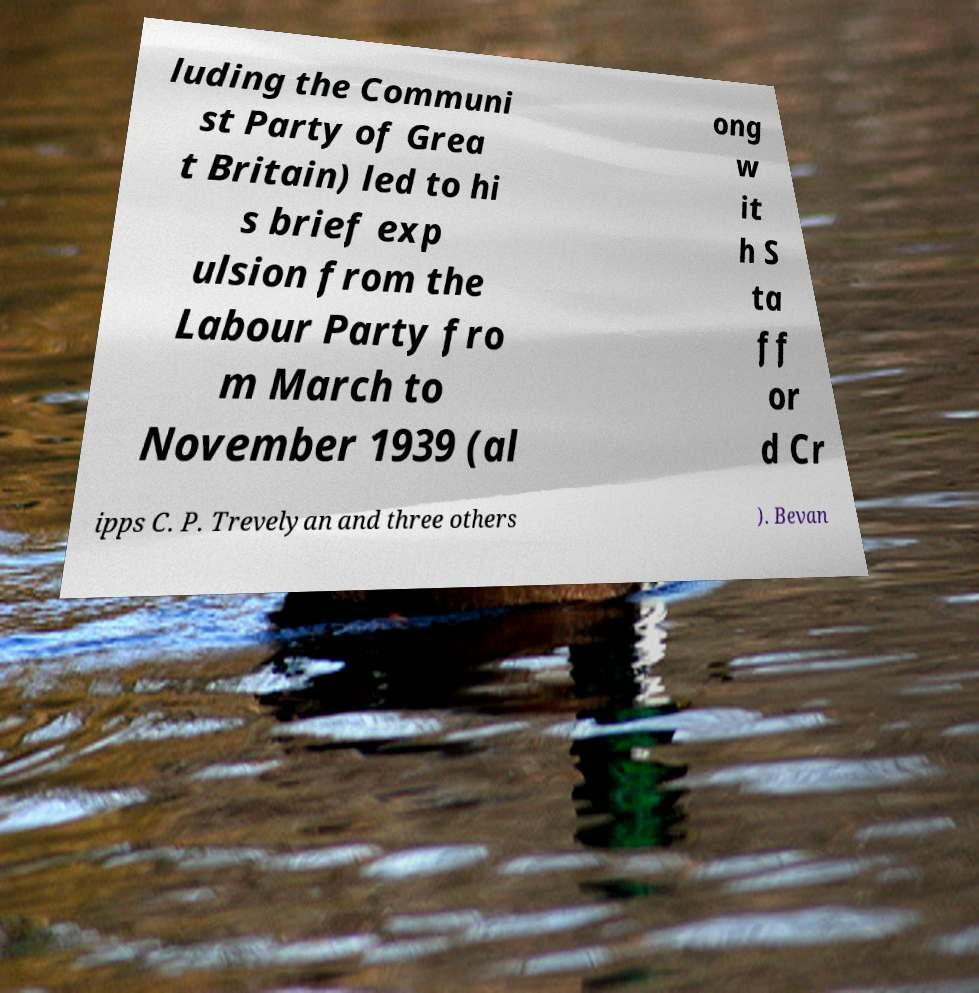Can you read and provide the text displayed in the image?This photo seems to have some interesting text. Can you extract and type it out for me? luding the Communi st Party of Grea t Britain) led to hi s brief exp ulsion from the Labour Party fro m March to November 1939 (al ong w it h S ta ff or d Cr ipps C. P. Trevelyan and three others ). Bevan 